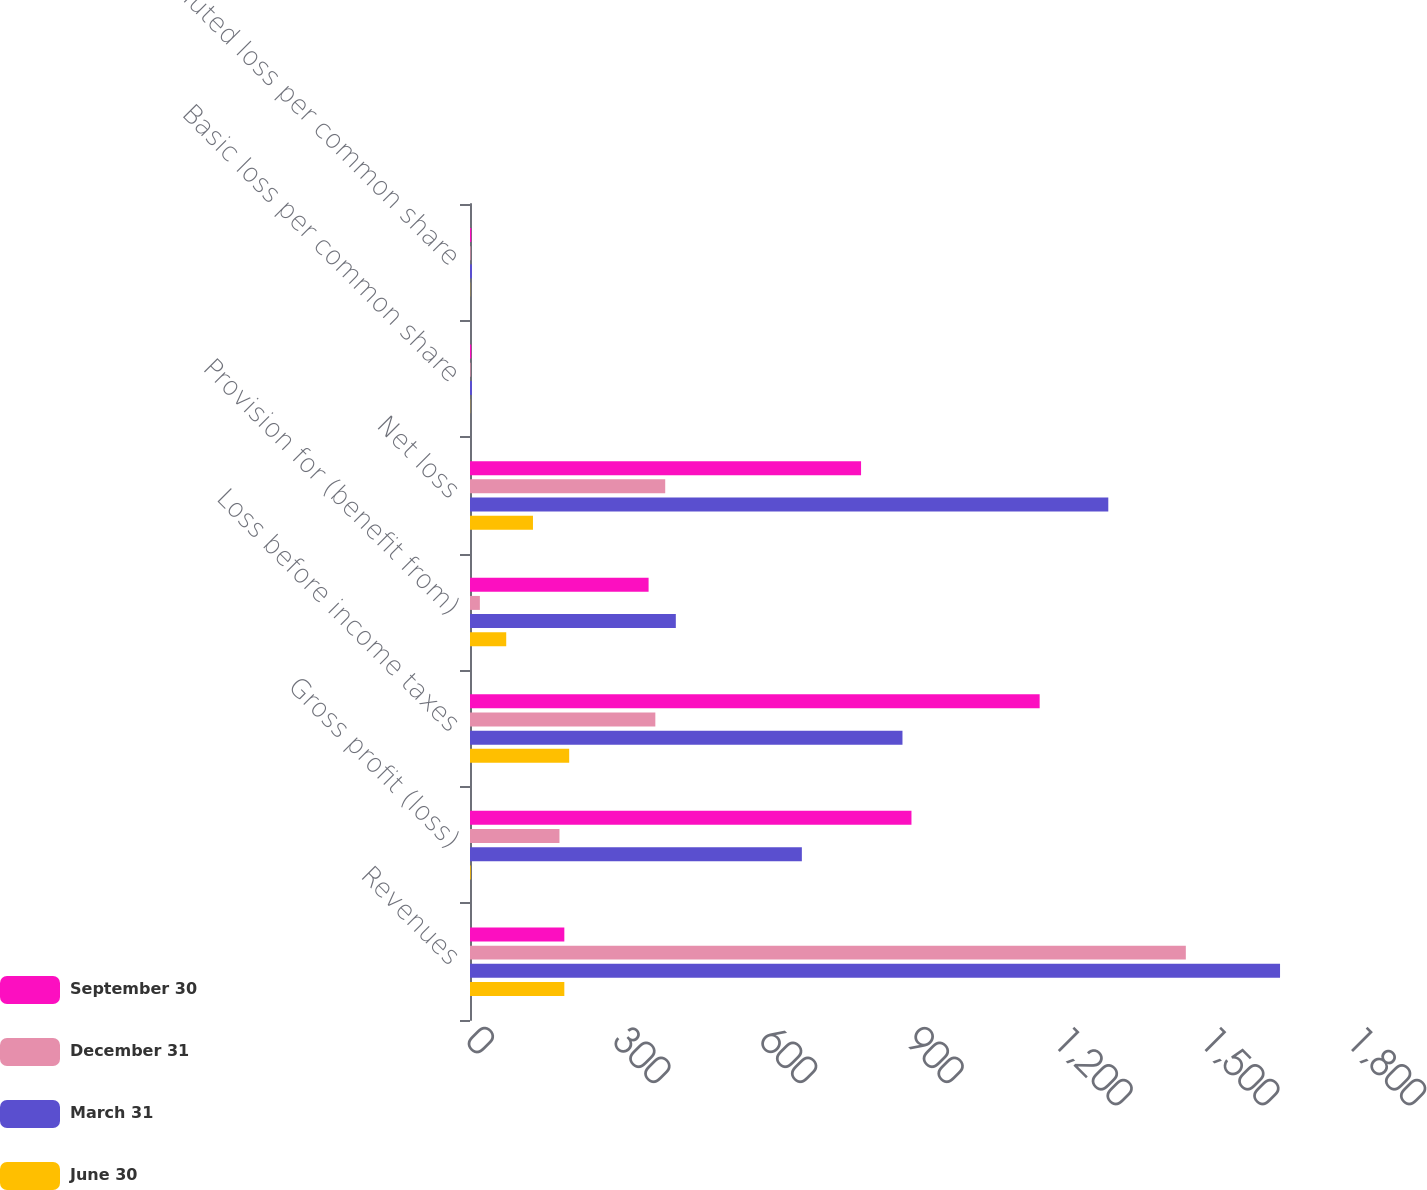<chart> <loc_0><loc_0><loc_500><loc_500><stacked_bar_chart><ecel><fcel>Revenues<fcel>Gross profit (loss)<fcel>Loss before income taxes<fcel>Provision for (benefit from)<fcel>Net loss<fcel>Basic loss per common share<fcel>Diluted loss per common share<nl><fcel>September 30<fcel>192.95<fcel>903<fcel>1165.2<fcel>365.3<fcel>799.9<fcel>2.53<fcel>2.53<nl><fcel>December 31<fcel>1464.2<fcel>183<fcel>379.1<fcel>20.2<fcel>399.3<fcel>1.26<fcel>1.26<nl><fcel>March 31<fcel>1656.9<fcel>678.8<fcel>884.6<fcel>421<fcel>1305.6<fcel>4.14<fcel>4.14<nl><fcel>June 30<fcel>192.95<fcel>1.6<fcel>202.9<fcel>74.1<fcel>128.8<fcel>0.41<fcel>0.41<nl></chart> 